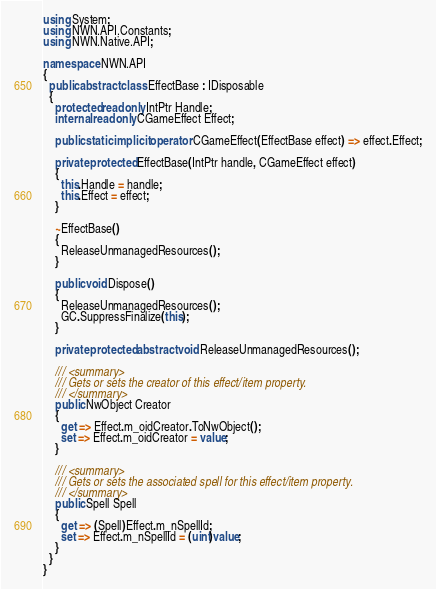<code> <loc_0><loc_0><loc_500><loc_500><_C#_>using System;
using NWN.API.Constants;
using NWN.Native.API;

namespace NWN.API
{
  public abstract class EffectBase : IDisposable
  {
    protected readonly IntPtr Handle;
    internal readonly CGameEffect Effect;

    public static implicit operator CGameEffect(EffectBase effect) => effect.Effect;

    private protected EffectBase(IntPtr handle, CGameEffect effect)
    {
      this.Handle = handle;
      this.Effect = effect;
    }

    ~EffectBase()
    {
      ReleaseUnmanagedResources();
    }

    public void Dispose()
    {
      ReleaseUnmanagedResources();
      GC.SuppressFinalize(this);
    }

    private protected abstract void ReleaseUnmanagedResources();

    /// <summary>
    /// Gets or sets the creator of this effect/item property.
    /// </summary>
    public NwObject Creator
    {
      get => Effect.m_oidCreator.ToNwObject();
      set => Effect.m_oidCreator = value;
    }

    /// <summary>
    /// Gets or sets the associated spell for this effect/item property.
    /// </summary>
    public Spell Spell
    {
      get => (Spell)Effect.m_nSpellId;
      set => Effect.m_nSpellId = (uint)value;
    }
  }
}
</code> 